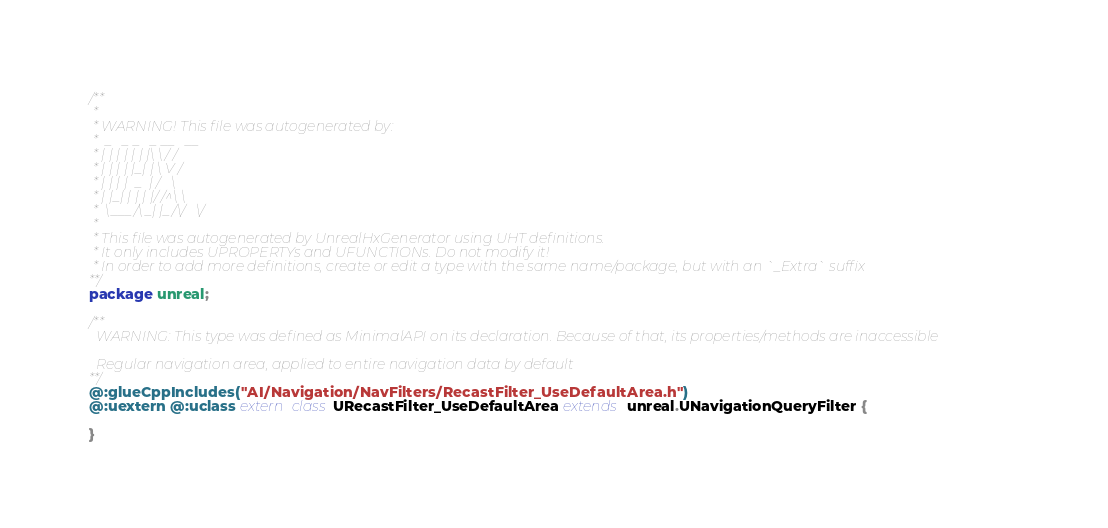<code> <loc_0><loc_0><loc_500><loc_500><_Haxe_>/**
 * 
 * WARNING! This file was autogenerated by: 
 *  _   _ _   _ __   __ 
 * | | | | | | |\ \ / / 
 * | | | | |_| | \ V /  
 * | | | |  _  | /   \  
 * | |_| | | | |/ /^\ \ 
 *  \___/\_| |_/\/   \/ 
 * 
 * This file was autogenerated by UnrealHxGenerator using UHT definitions.
 * It only includes UPROPERTYs and UFUNCTIONs. Do not modify it!
 * In order to add more definitions, create or edit a type with the same name/package, but with an `_Extra` suffix
**/
package unreal;

/**
  WARNING: This type was defined as MinimalAPI on its declaration. Because of that, its properties/methods are inaccessible
  
  Regular navigation area, applied to entire navigation data by default
**/
@:glueCppIncludes("AI/Navigation/NavFilters/RecastFilter_UseDefaultArea.h")
@:uextern @:uclass extern class URecastFilter_UseDefaultArea extends unreal.UNavigationQueryFilter {
  
}
</code> 